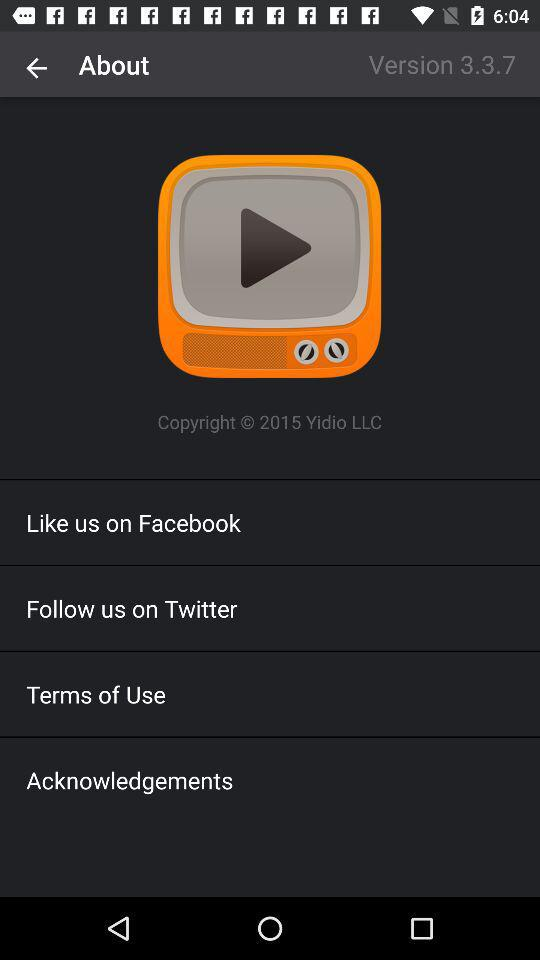On which app can a user like? A user can like on "Facebook". 